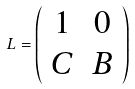<formula> <loc_0><loc_0><loc_500><loc_500>L = \left ( \begin{array} { c c } 1 & 0 \\ C & B \end{array} \right )</formula> 